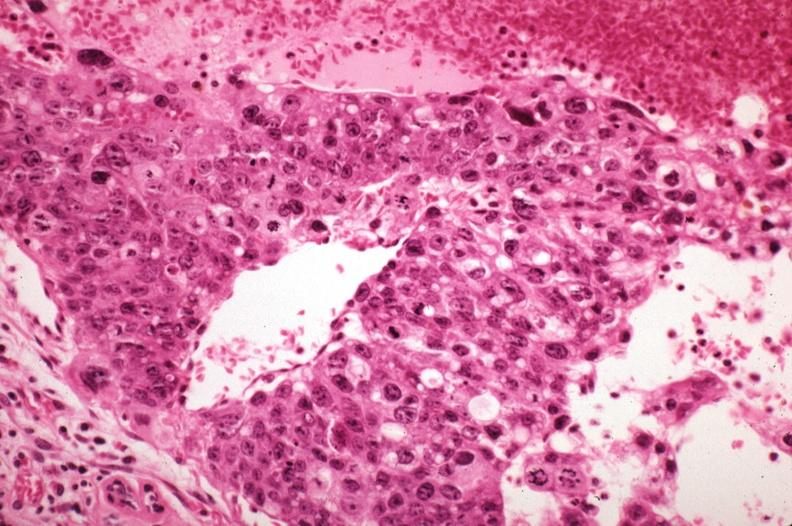s metastatic carcinoma present?
Answer the question using a single word or phrase. Yes 